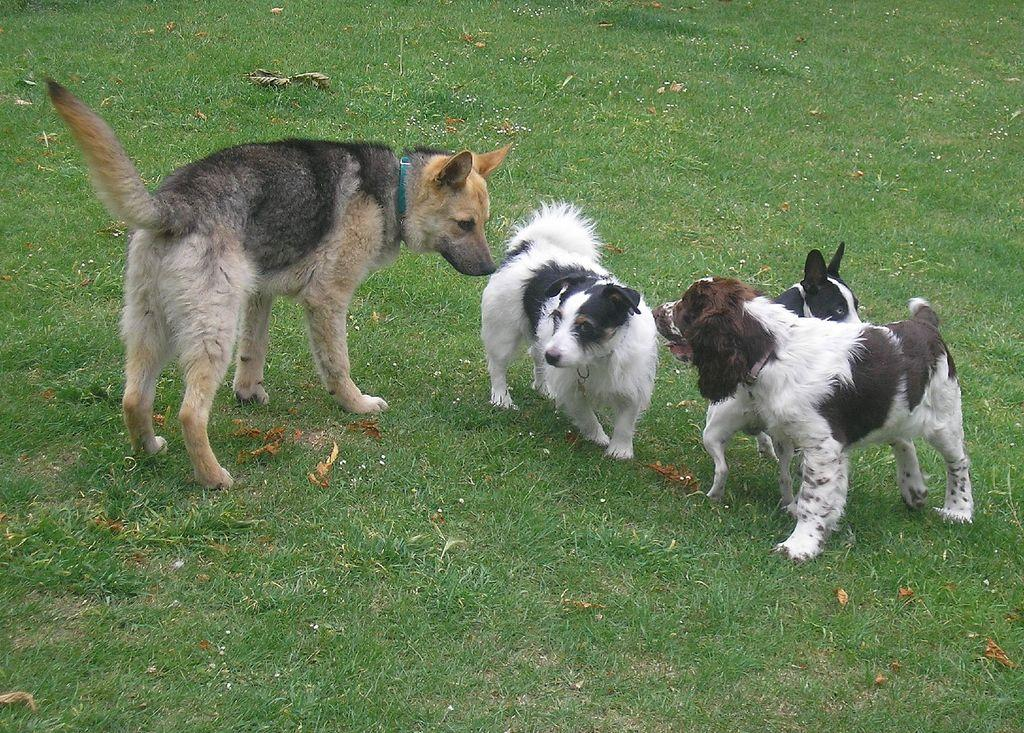What type of animals are in the image? There are dogs in the image. Where are the dogs located? The dogs are on the ground. What type of terrain is visible in the image? There is grass visible in the image. How does the grass provide pleasure to the dogs in the image? The image does not show the dogs experiencing pleasure from the grass; it only shows them on the ground. 